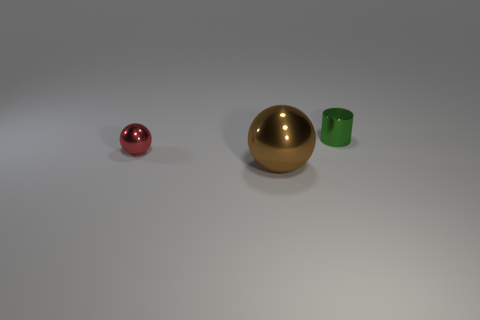What number of other objects are the same material as the tiny red thing?
Ensure brevity in your answer.  2. How many yellow objects are large spheres or small balls?
Offer a terse response. 0. Do the tiny metal thing in front of the tiny green metallic cylinder and the small metal object that is to the right of the big brown ball have the same shape?
Give a very brief answer. No. There is a metallic cylinder; is it the same color as the tiny shiny thing that is to the left of the cylinder?
Keep it short and to the point. No. Is the color of the tiny metallic object to the right of the large brown object the same as the large thing?
Give a very brief answer. No. How many things are either large red shiny cubes or objects behind the tiny ball?
Offer a very short reply. 1. What is the material of the thing that is both right of the small red ball and behind the brown metal object?
Offer a very short reply. Metal. What material is the green cylinder that is behind the tiny metallic ball?
Your answer should be compact. Metal. What color is the small cylinder that is the same material as the small red object?
Ensure brevity in your answer.  Green. There is a tiny red object; is its shape the same as the thing that is behind the red metal thing?
Offer a terse response. No. 